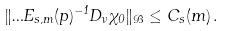Convert formula to latex. <formula><loc_0><loc_0><loc_500><loc_500>\| \Phi E _ { s , m } ( p ) ^ { - 1 } D _ { \nu } \chi _ { 0 } \| _ { \mathcal { B } } \leq C _ { s } ( m ) \, .</formula> 